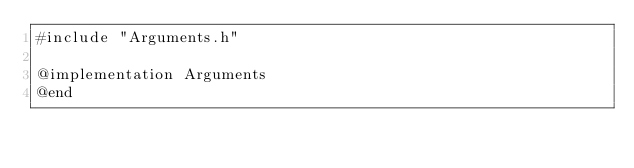Convert code to text. <code><loc_0><loc_0><loc_500><loc_500><_ObjectiveC_>#include "Arguments.h"

@implementation Arguments
@end</code> 